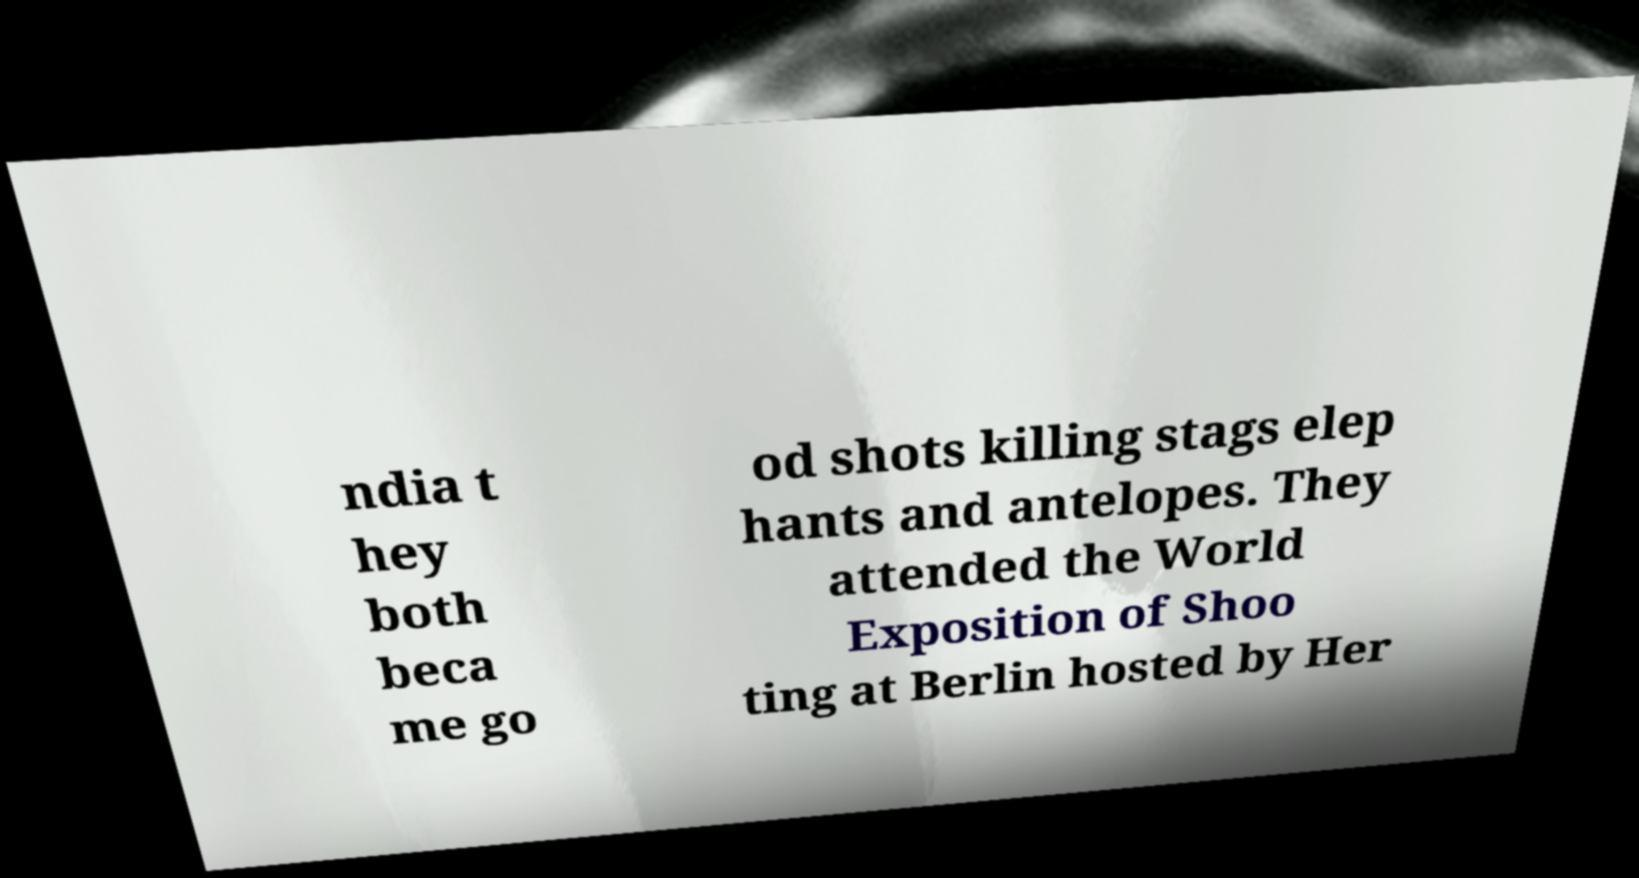Please read and relay the text visible in this image. What does it say? ndia t hey both beca me go od shots killing stags elep hants and antelopes. They attended the World Exposition of Shoo ting at Berlin hosted by Her 